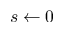<formula> <loc_0><loc_0><loc_500><loc_500>s \gets 0</formula> 